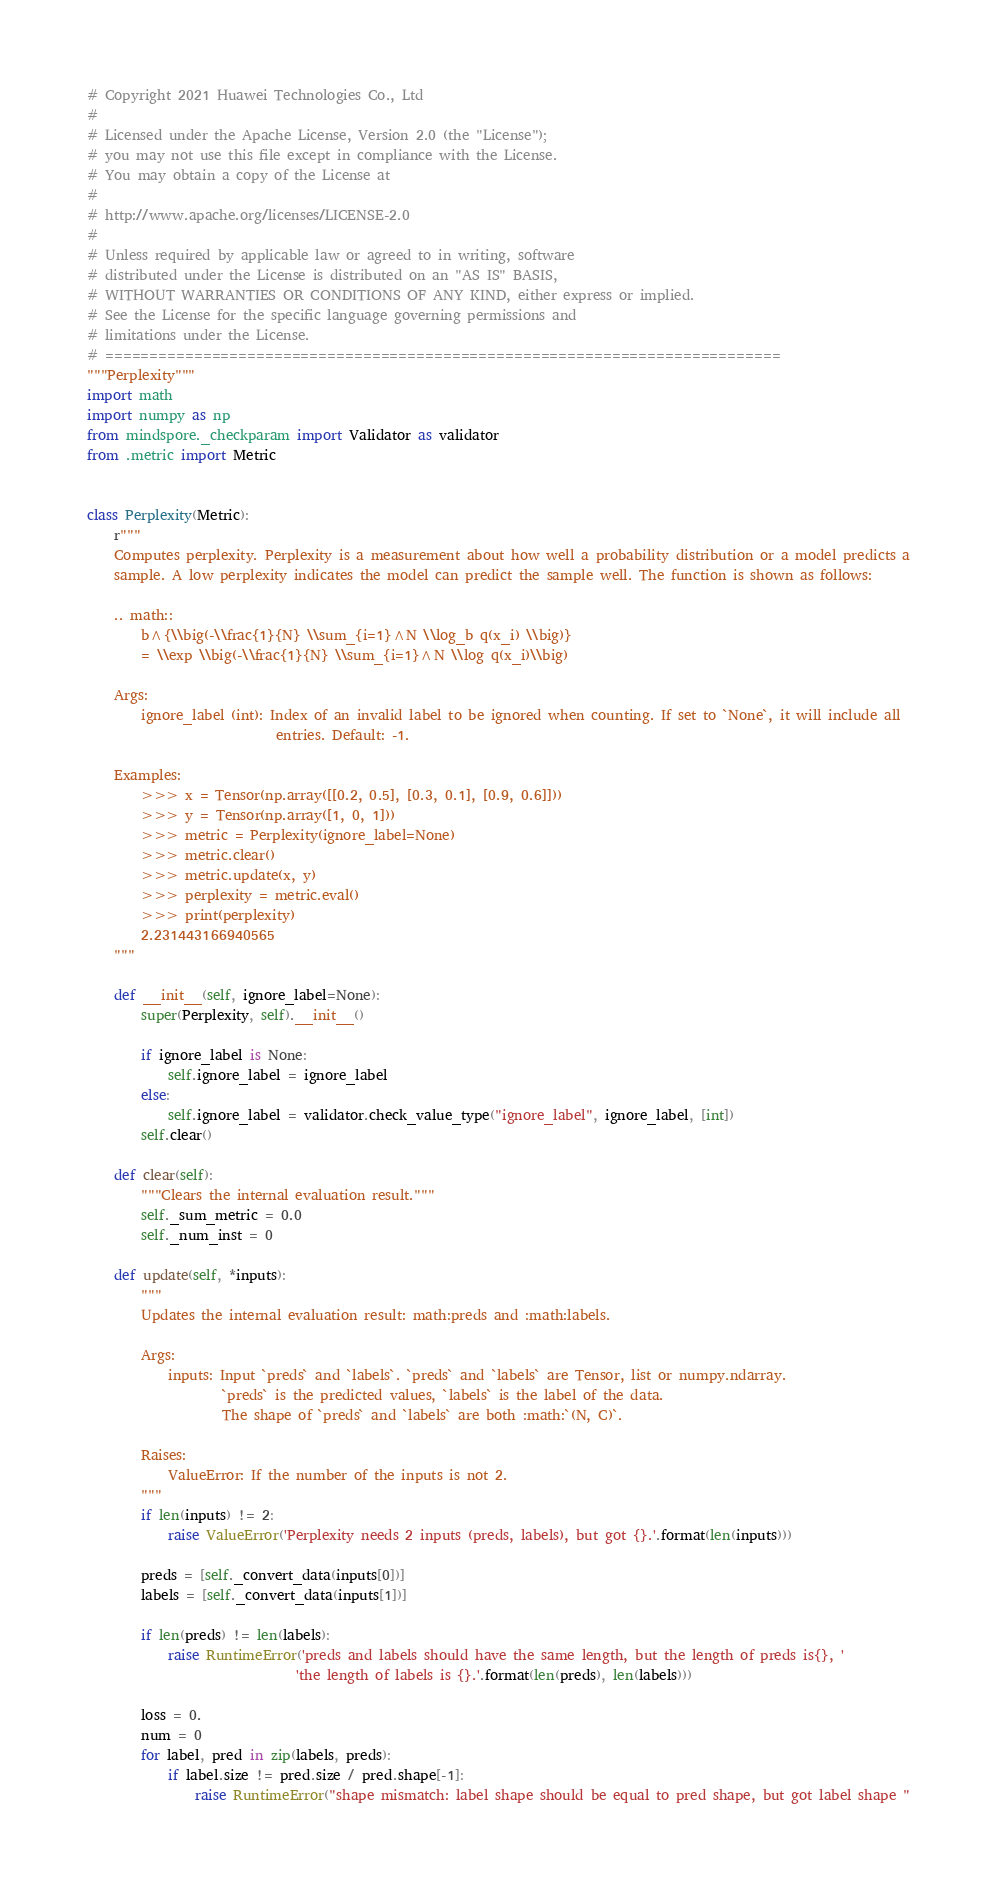<code> <loc_0><loc_0><loc_500><loc_500><_Python_># Copyright 2021 Huawei Technologies Co., Ltd
#
# Licensed under the Apache License, Version 2.0 (the "License");
# you may not use this file except in compliance with the License.
# You may obtain a copy of the License at
#
# http://www.apache.org/licenses/LICENSE-2.0
#
# Unless required by applicable law or agreed to in writing, software
# distributed under the License is distributed on an "AS IS" BASIS,
# WITHOUT WARRANTIES OR CONDITIONS OF ANY KIND, either express or implied.
# See the License for the specific language governing permissions and
# limitations under the License.
# ============================================================================
"""Perplexity"""
import math
import numpy as np
from mindspore._checkparam import Validator as validator
from .metric import Metric


class Perplexity(Metric):
    r"""
    Computes perplexity. Perplexity is a measurement about how well a probability distribution or a model predicts a
    sample. A low perplexity indicates the model can predict the sample well. The function is shown as follows:

    .. math::
        b^{\\big(-\\frac{1}{N} \\sum_{i=1}^N \\log_b q(x_i) \\big)}
        = \\exp \\big(-\\frac{1}{N} \\sum_{i=1}^N \\log q(x_i)\\big)

    Args:
        ignore_label (int): Index of an invalid label to be ignored when counting. If set to `None`, it will include all
                            entries. Default: -1.

    Examples:
        >>> x = Tensor(np.array([[0.2, 0.5], [0.3, 0.1], [0.9, 0.6]]))
        >>> y = Tensor(np.array([1, 0, 1]))
        >>> metric = Perplexity(ignore_label=None)
        >>> metric.clear()
        >>> metric.update(x, y)
        >>> perplexity = metric.eval()
        >>> print(perplexity)
        2.231443166940565
    """

    def __init__(self, ignore_label=None):
        super(Perplexity, self).__init__()

        if ignore_label is None:
            self.ignore_label = ignore_label
        else:
            self.ignore_label = validator.check_value_type("ignore_label", ignore_label, [int])
        self.clear()

    def clear(self):
        """Clears the internal evaluation result."""
        self._sum_metric = 0.0
        self._num_inst = 0

    def update(self, *inputs):
        """
        Updates the internal evaluation result: math:preds and :math:labels.

        Args:
            inputs: Input `preds` and `labels`. `preds` and `labels` are Tensor, list or numpy.ndarray.
                    `preds` is the predicted values, `labels` is the label of the data.
                    The shape of `preds` and `labels` are both :math:`(N, C)`.

        Raises:
            ValueError: If the number of the inputs is not 2.
        """
        if len(inputs) != 2:
            raise ValueError('Perplexity needs 2 inputs (preds, labels), but got {}.'.format(len(inputs)))

        preds = [self._convert_data(inputs[0])]
        labels = [self._convert_data(inputs[1])]

        if len(preds) != len(labels):
            raise RuntimeError('preds and labels should have the same length, but the length of preds is{}, '
                               'the length of labels is {}.'.format(len(preds), len(labels)))

        loss = 0.
        num = 0
        for label, pred in zip(labels, preds):
            if label.size != pred.size / pred.shape[-1]:
                raise RuntimeError("shape mismatch: label shape should be equal to pred shape, but got label shape "</code> 